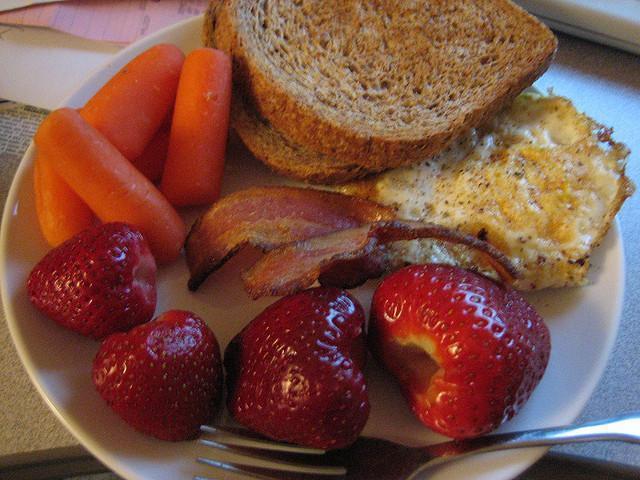How many bacon does it have on the plate?
Give a very brief answer. 2. How many carrots can you see?
Give a very brief answer. 3. How many sandwiches are there?
Give a very brief answer. 2. 